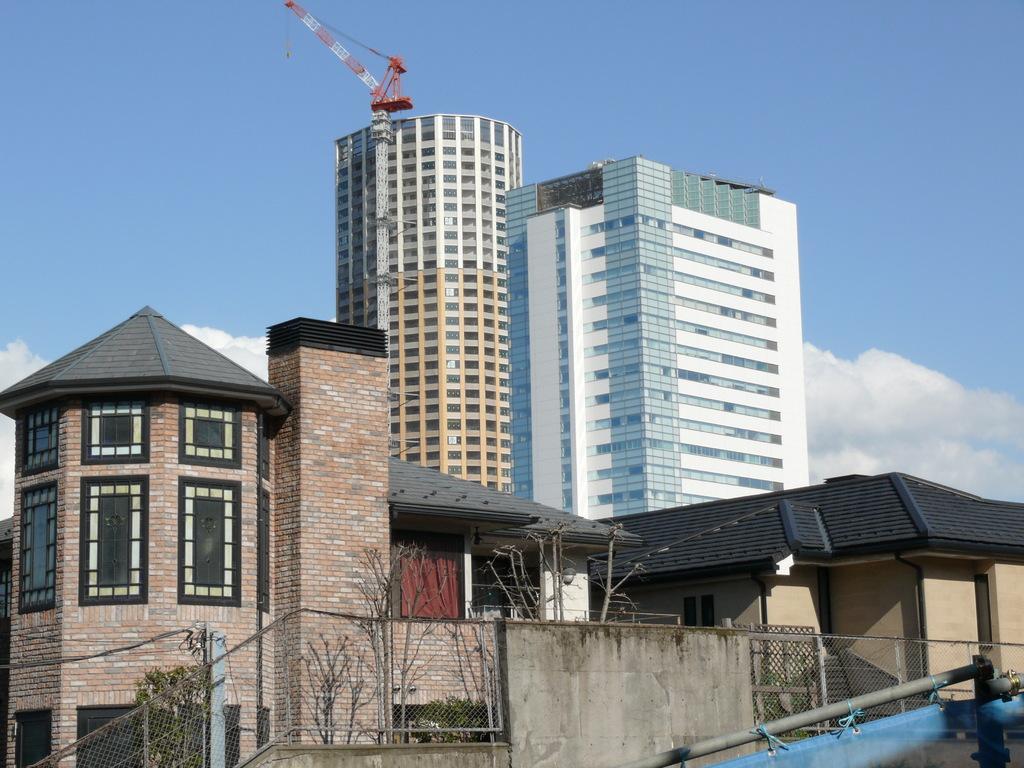How would you summarize this image in a sentence or two? This picture is clicked outside. In the foreground we can see the mesh, metal rods, trees and some other objects. In the center we can see the buildings. In the background we can see the sky and we can see a curtain and we can see the clouds in the background and the metal rods and some other objects. 